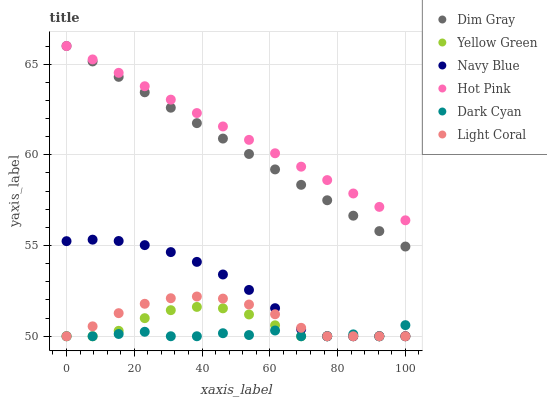Does Dark Cyan have the minimum area under the curve?
Answer yes or no. Yes. Does Hot Pink have the maximum area under the curve?
Answer yes or no. Yes. Does Yellow Green have the minimum area under the curve?
Answer yes or no. No. Does Yellow Green have the maximum area under the curve?
Answer yes or no. No. Is Hot Pink the smoothest?
Answer yes or no. Yes. Is Dark Cyan the roughest?
Answer yes or no. Yes. Is Yellow Green the smoothest?
Answer yes or no. No. Is Yellow Green the roughest?
Answer yes or no. No. Does Yellow Green have the lowest value?
Answer yes or no. Yes. Does Hot Pink have the lowest value?
Answer yes or no. No. Does Hot Pink have the highest value?
Answer yes or no. Yes. Does Yellow Green have the highest value?
Answer yes or no. No. Is Light Coral less than Hot Pink?
Answer yes or no. Yes. Is Hot Pink greater than Navy Blue?
Answer yes or no. Yes. Does Yellow Green intersect Light Coral?
Answer yes or no. Yes. Is Yellow Green less than Light Coral?
Answer yes or no. No. Is Yellow Green greater than Light Coral?
Answer yes or no. No. Does Light Coral intersect Hot Pink?
Answer yes or no. No. 